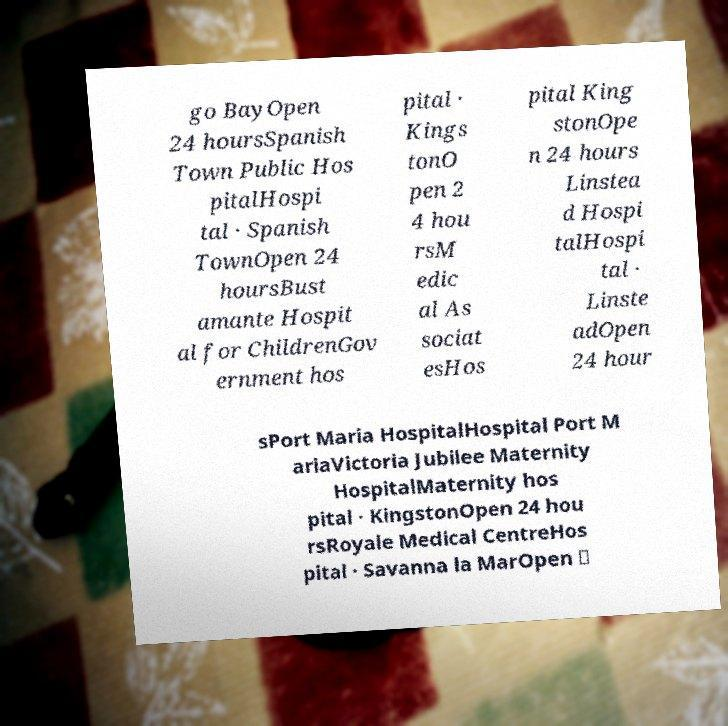Can you accurately transcribe the text from the provided image for me? go BayOpen 24 hoursSpanish Town Public Hos pitalHospi tal · Spanish TownOpen 24 hoursBust amante Hospit al for ChildrenGov ernment hos pital · Kings tonO pen 2 4 hou rsM edic al As sociat esHos pital King stonOpe n 24 hours Linstea d Hospi talHospi tal · Linste adOpen 24 hour sPort Maria HospitalHospital Port M ariaVictoria Jubilee Maternity HospitalMaternity hos pital · KingstonOpen 24 hou rsRoyale Medical CentreHos pital · Savanna la MarOpen ⋅ 